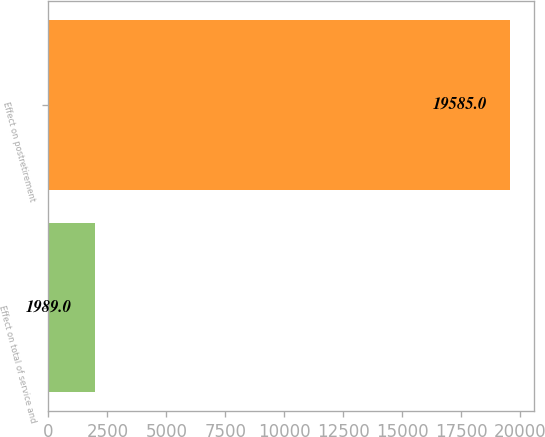Convert chart to OTSL. <chart><loc_0><loc_0><loc_500><loc_500><bar_chart><fcel>Effect on total of service and<fcel>Effect on postretirement<nl><fcel>1989<fcel>19585<nl></chart> 